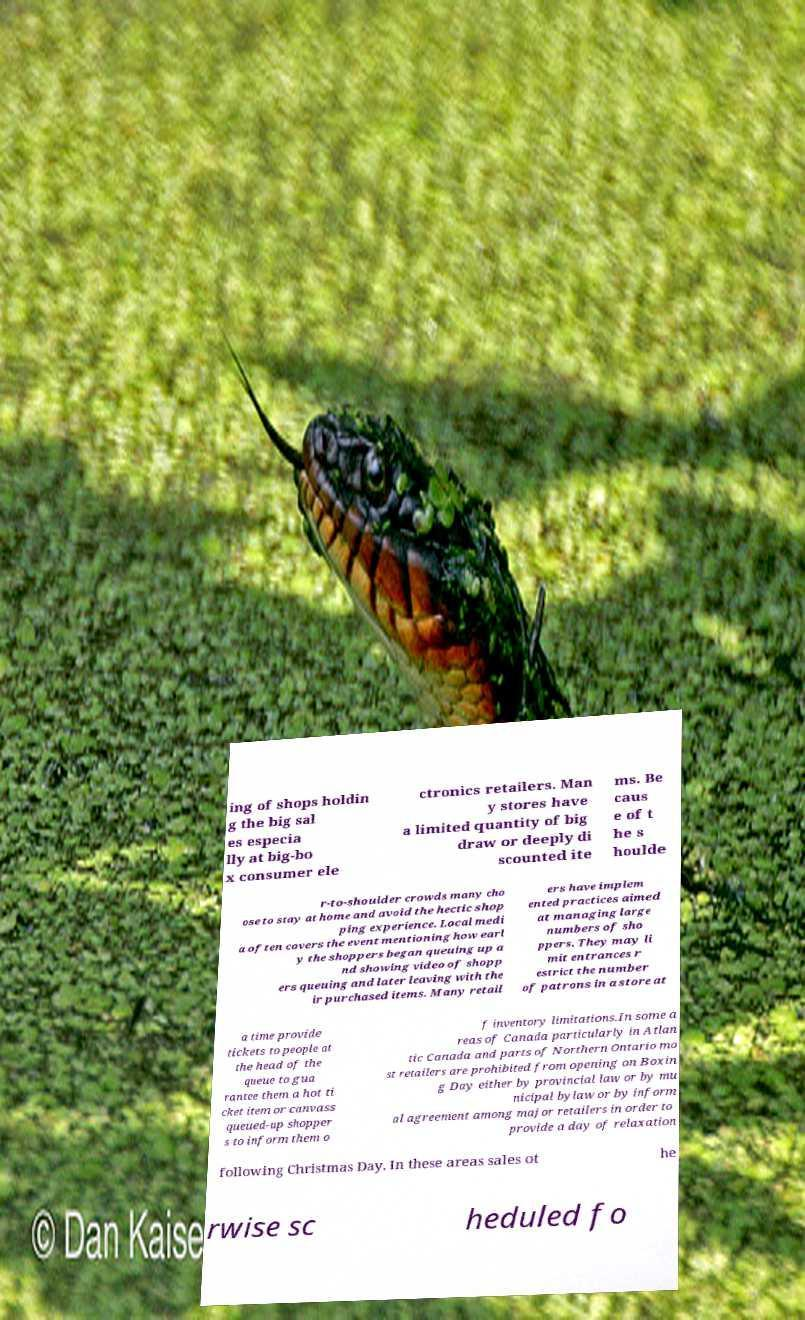What messages or text are displayed in this image? I need them in a readable, typed format. ing of shops holdin g the big sal es especia lly at big-bo x consumer ele ctronics retailers. Man y stores have a limited quantity of big draw or deeply di scounted ite ms. Be caus e of t he s houlde r-to-shoulder crowds many cho ose to stay at home and avoid the hectic shop ping experience. Local medi a often covers the event mentioning how earl y the shoppers began queuing up a nd showing video of shopp ers queuing and later leaving with the ir purchased items. Many retail ers have implem ented practices aimed at managing large numbers of sho ppers. They may li mit entrances r estrict the number of patrons in a store at a time provide tickets to people at the head of the queue to gua rantee them a hot ti cket item or canvass queued-up shopper s to inform them o f inventory limitations.In some a reas of Canada particularly in Atlan tic Canada and parts of Northern Ontario mo st retailers are prohibited from opening on Boxin g Day either by provincial law or by mu nicipal bylaw or by inform al agreement among major retailers in order to provide a day of relaxation following Christmas Day. In these areas sales ot he rwise sc heduled fo 